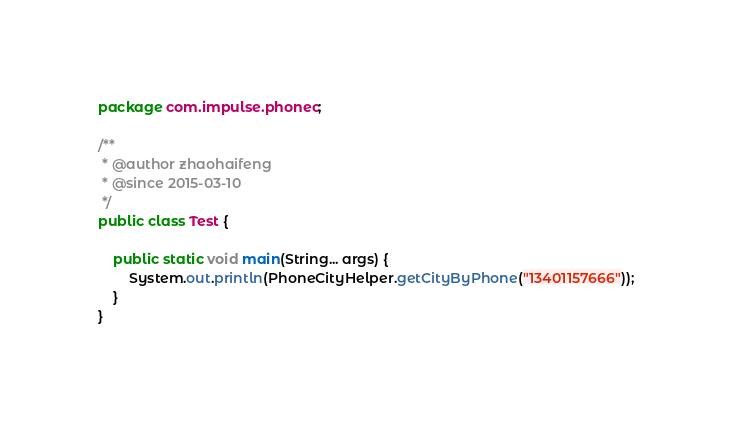Convert code to text. <code><loc_0><loc_0><loc_500><loc_500><_Java_>package com.impulse.phonec;

/**
 * @author zhaohaifeng
 * @since 2015-03-10
 */
public class Test {

    public static void main(String... args) {
        System.out.println(PhoneCityHelper.getCityByPhone("13401157666"));
    }
}
</code> 